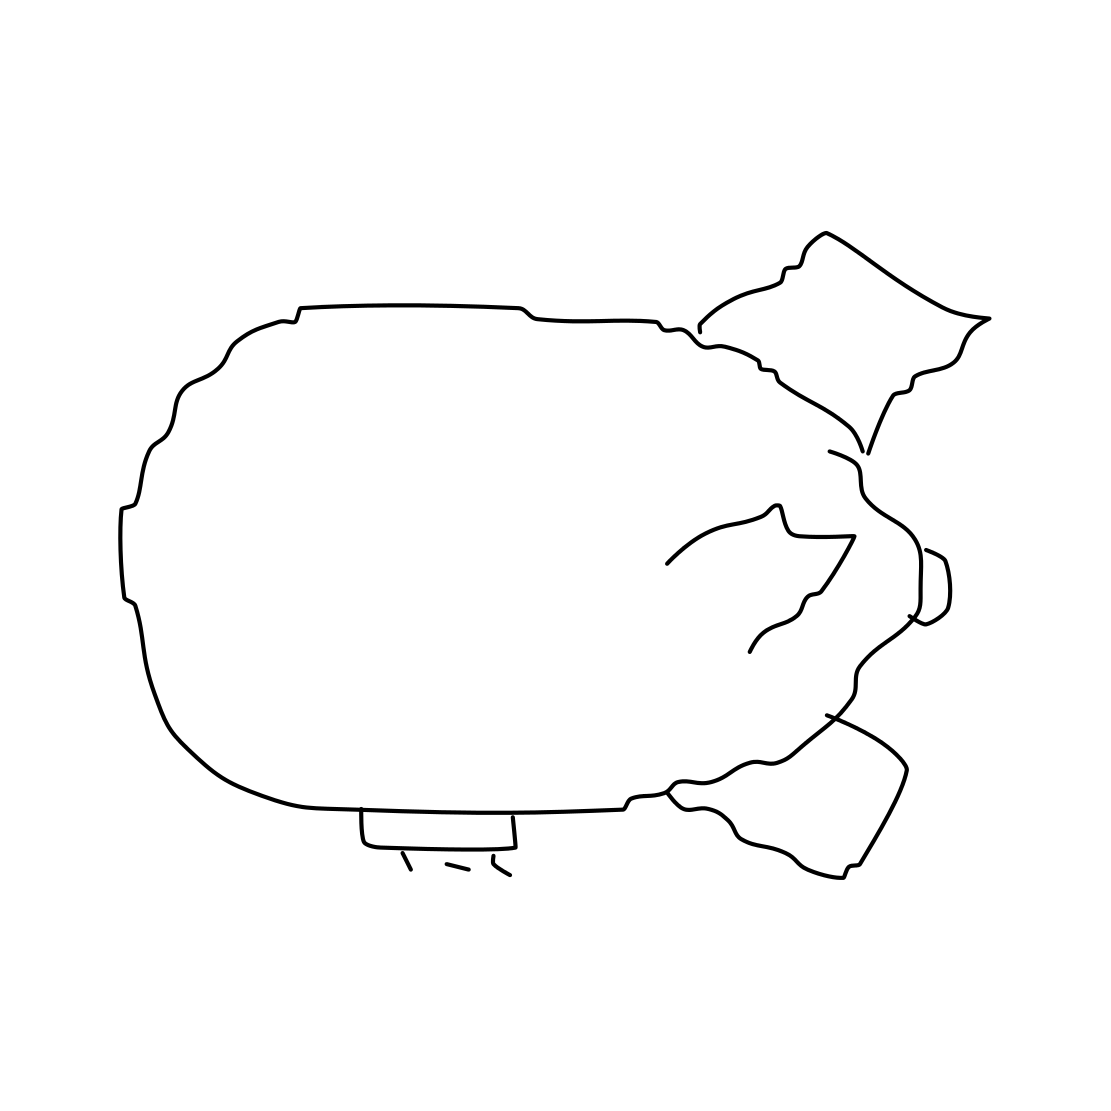Could this blimp be representative of a particular era or style? While it's a simple sketch, the blimp could be seen as reminiscent of the early-to-mid 20th century, an era when blimps were more prevalent and often employed for both civilian and military uses. The minimalist style of the drawing lends it a timeless quality that could make it relevant to various artistic or historical contexts. 